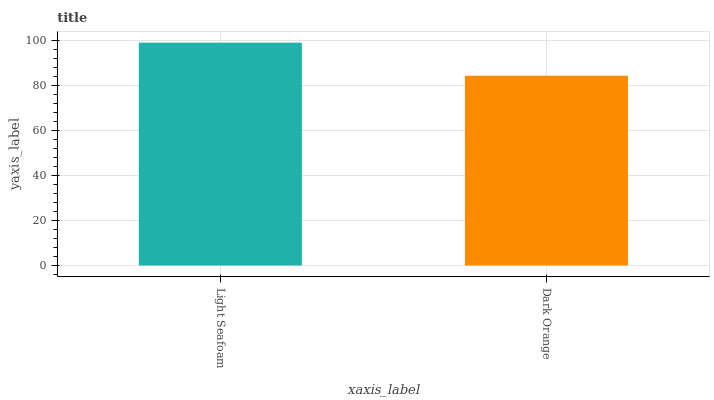Is Dark Orange the minimum?
Answer yes or no. Yes. Is Light Seafoam the maximum?
Answer yes or no. Yes. Is Dark Orange the maximum?
Answer yes or no. No. Is Light Seafoam greater than Dark Orange?
Answer yes or no. Yes. Is Dark Orange less than Light Seafoam?
Answer yes or no. Yes. Is Dark Orange greater than Light Seafoam?
Answer yes or no. No. Is Light Seafoam less than Dark Orange?
Answer yes or no. No. Is Light Seafoam the high median?
Answer yes or no. Yes. Is Dark Orange the low median?
Answer yes or no. Yes. Is Dark Orange the high median?
Answer yes or no. No. Is Light Seafoam the low median?
Answer yes or no. No. 